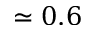<formula> <loc_0><loc_0><loc_500><loc_500>\simeq 0 . 6</formula> 